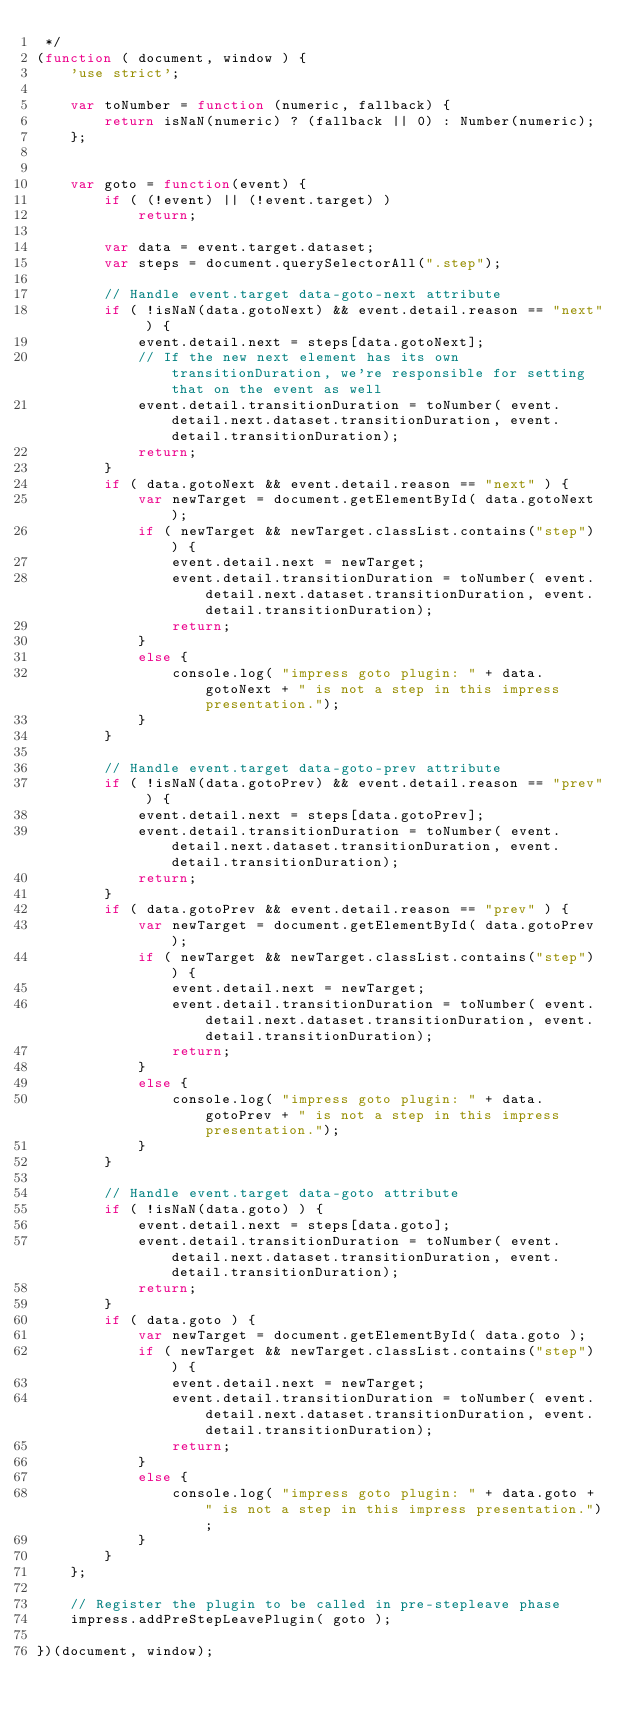<code> <loc_0><loc_0><loc_500><loc_500><_JavaScript_> */
(function ( document, window ) {
    'use strict';

    var toNumber = function (numeric, fallback) {
        return isNaN(numeric) ? (fallback || 0) : Number(numeric);
    };

            
    var goto = function(event) {
        if ( (!event) || (!event.target) )
            return;
        
        var data = event.target.dataset;
        var steps = document.querySelectorAll(".step");
        
        // Handle event.target data-goto-next attribute
        if ( !isNaN(data.gotoNext) && event.detail.reason == "next" ) {
            event.detail.next = steps[data.gotoNext];
            // If the new next element has its own transitionDuration, we're responsible for setting that on the event as well
            event.detail.transitionDuration = toNumber( event.detail.next.dataset.transitionDuration, event.detail.transitionDuration);
            return;
        }
        if ( data.gotoNext && event.detail.reason == "next" ) {
            var newTarget = document.getElementById( data.gotoNext );
            if ( newTarget && newTarget.classList.contains("step") ) {
                event.detail.next = newTarget;
                event.detail.transitionDuration = toNumber( event.detail.next.dataset.transitionDuration, event.detail.transitionDuration);
                return;
            }
            else {
                console.log( "impress goto plugin: " + data.gotoNext + " is not a step in this impress presentation.");
            }
        }

        // Handle event.target data-goto-prev attribute
        if ( !isNaN(data.gotoPrev) && event.detail.reason == "prev" ) {
            event.detail.next = steps[data.gotoPrev];
            event.detail.transitionDuration = toNumber( event.detail.next.dataset.transitionDuration, event.detail.transitionDuration);
            return;
        }
        if ( data.gotoPrev && event.detail.reason == "prev" ) {
            var newTarget = document.getElementById( data.gotoPrev );
            if ( newTarget && newTarget.classList.contains("step") ) {
                event.detail.next = newTarget;
                event.detail.transitionDuration = toNumber( event.detail.next.dataset.transitionDuration, event.detail.transitionDuration);
                return;
            }
            else {
                console.log( "impress goto plugin: " + data.gotoPrev + " is not a step in this impress presentation.");
            }
        }

        // Handle event.target data-goto attribute
        if ( !isNaN(data.goto) ) {
            event.detail.next = steps[data.goto];
            event.detail.transitionDuration = toNumber( event.detail.next.dataset.transitionDuration, event.detail.transitionDuration);
            return;
        }
        if ( data.goto ) {
            var newTarget = document.getElementById( data.goto );
            if ( newTarget && newTarget.classList.contains("step") ) {
                event.detail.next = newTarget;
                event.detail.transitionDuration = toNumber( event.detail.next.dataset.transitionDuration, event.detail.transitionDuration);
                return;
            }
            else {
                console.log( "impress goto plugin: " + data.goto + " is not a step in this impress presentation.");
            }
        }
    };
    
    // Register the plugin to be called in pre-stepleave phase
    impress.addPreStepLeavePlugin( goto );
    
})(document, window);

</code> 